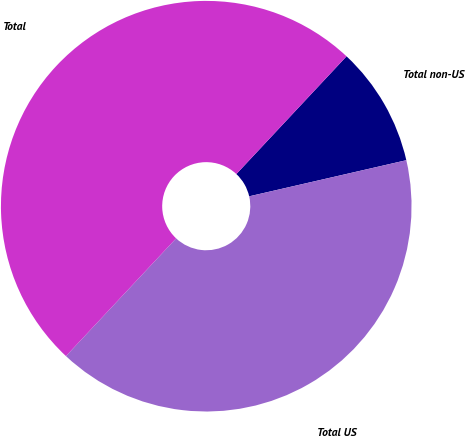Convert chart. <chart><loc_0><loc_0><loc_500><loc_500><pie_chart><fcel>Total non-US<fcel>Total US<fcel>Total<nl><fcel>9.43%<fcel>40.57%<fcel>50.0%<nl></chart> 